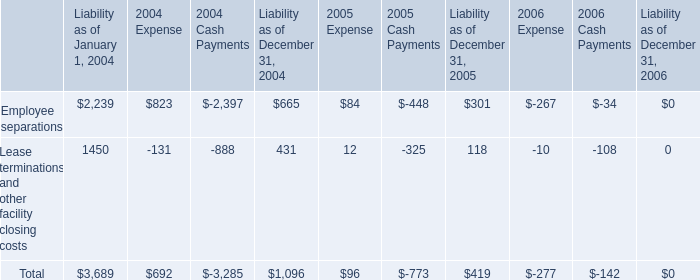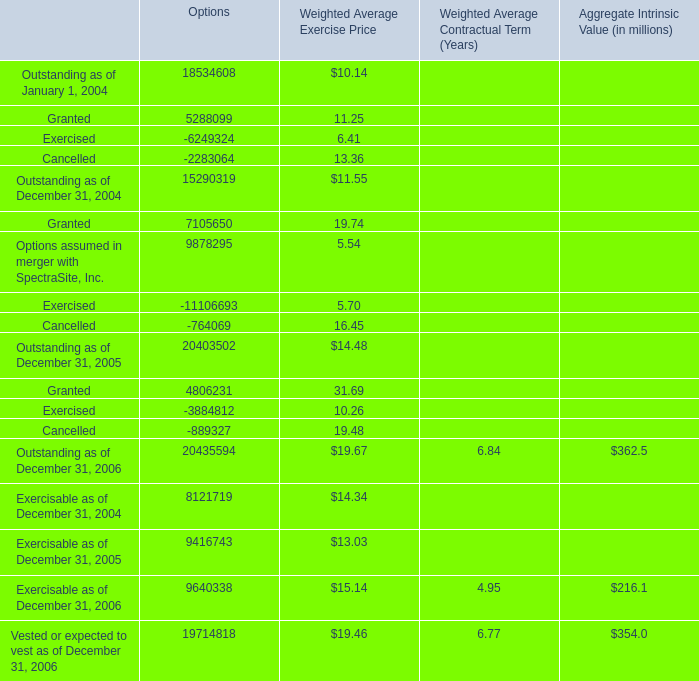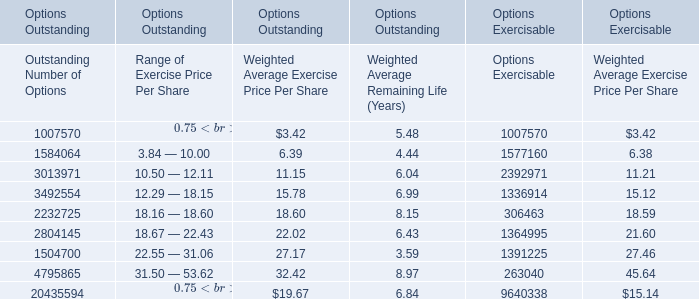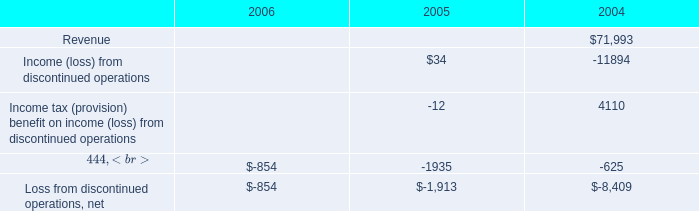What's the difference of Options' Outstanding as of December 31 between 2004 and 2005? 
Computations: (20403502 - 15290319)
Answer: 5113183.0. 